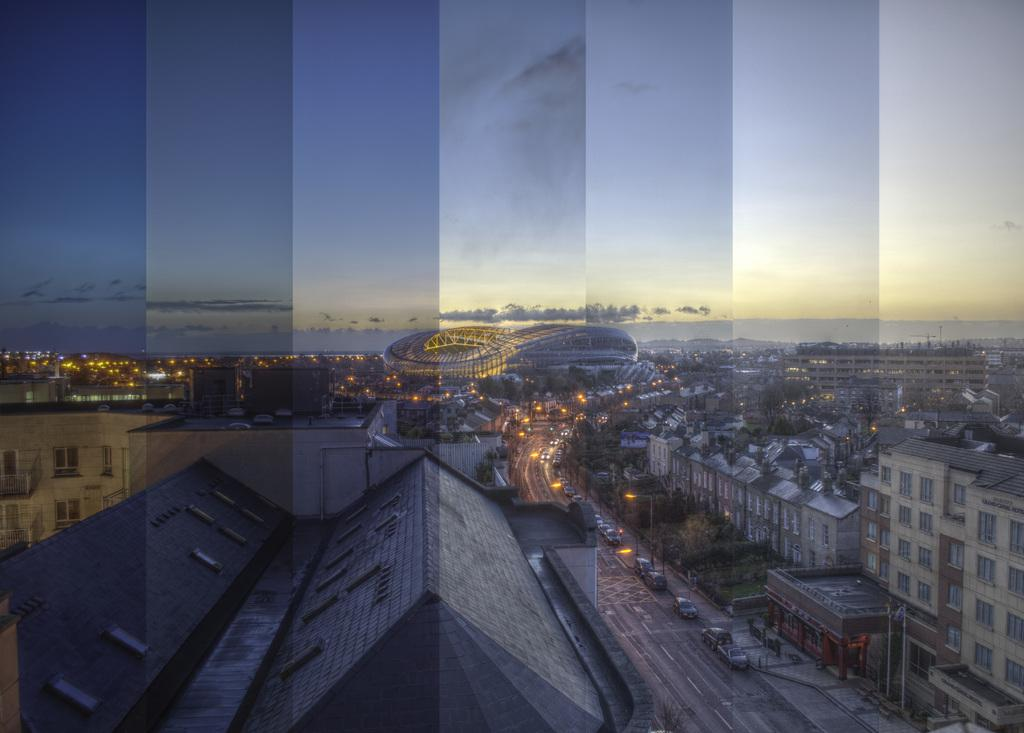What is present on the road in the image? There are vehicles on the road in the image. How are the buildings in the image characterized? The buildings in the image are in cream and gray colors. What can be seen in the background of the image? There are trees visible in the background of the image. What is the color of the sky in the image? The sky in the image is blue and white. Where is the faucet located in the image? There is no faucet present in the image. What type of blade can be seen in the image? There is no blade present in the image. 